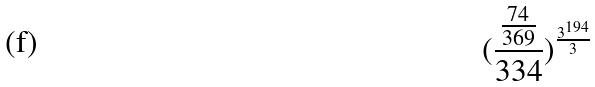Convert formula to latex. <formula><loc_0><loc_0><loc_500><loc_500>( \frac { \frac { 7 4 } { 3 6 9 } } { 3 3 4 } ) ^ { \frac { 3 ^ { 1 9 4 } } { 3 } }</formula> 